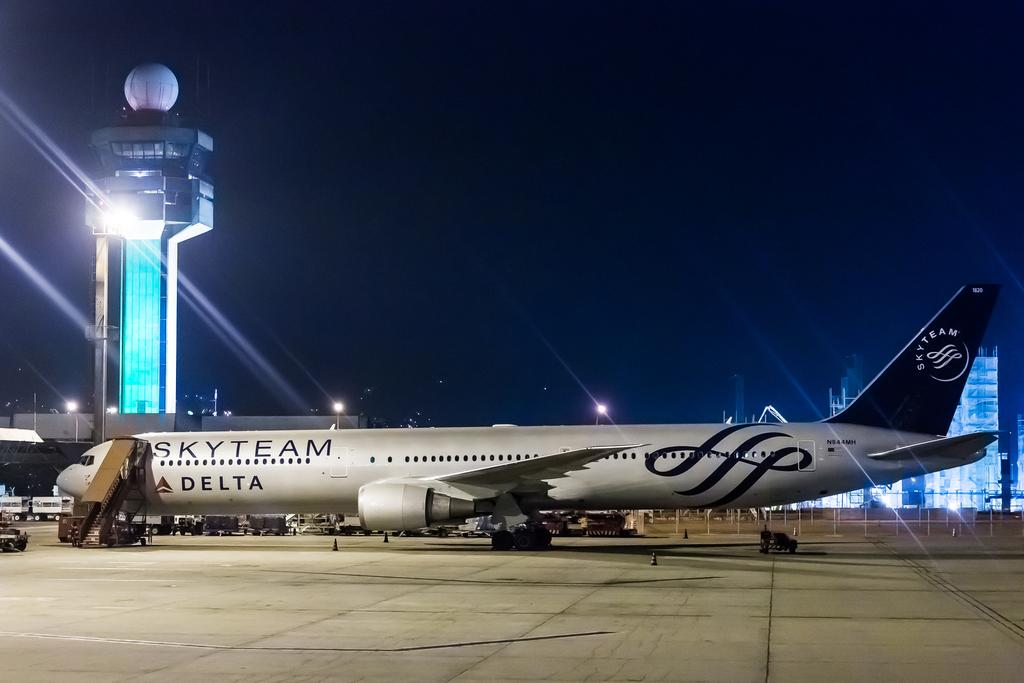<image>
Offer a succinct explanation of the picture presented. A white Skyteam Delta jet is parked at an airport. 